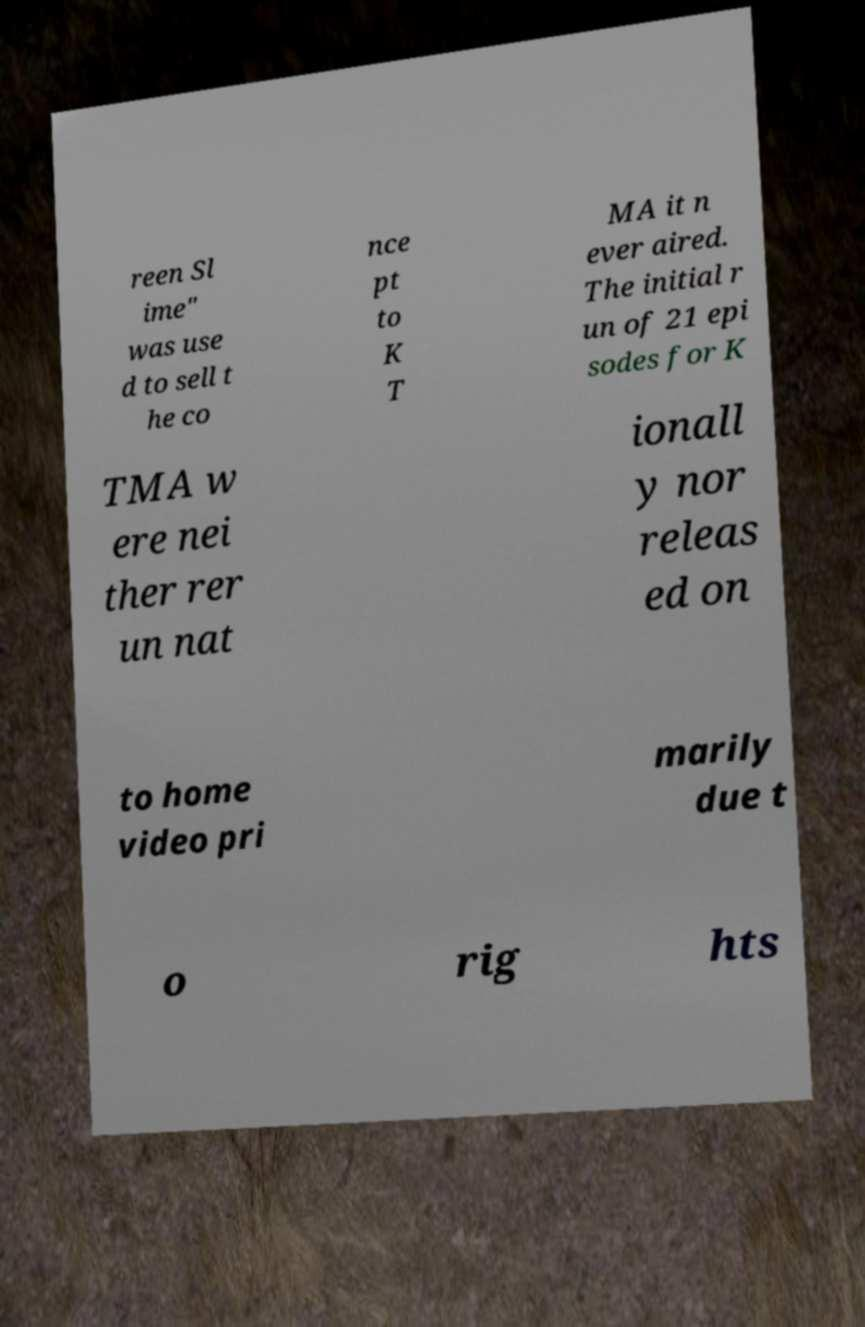Can you read and provide the text displayed in the image?This photo seems to have some interesting text. Can you extract and type it out for me? reen Sl ime" was use d to sell t he co nce pt to K T MA it n ever aired. The initial r un of 21 epi sodes for K TMA w ere nei ther rer un nat ionall y nor releas ed on to home video pri marily due t o rig hts 